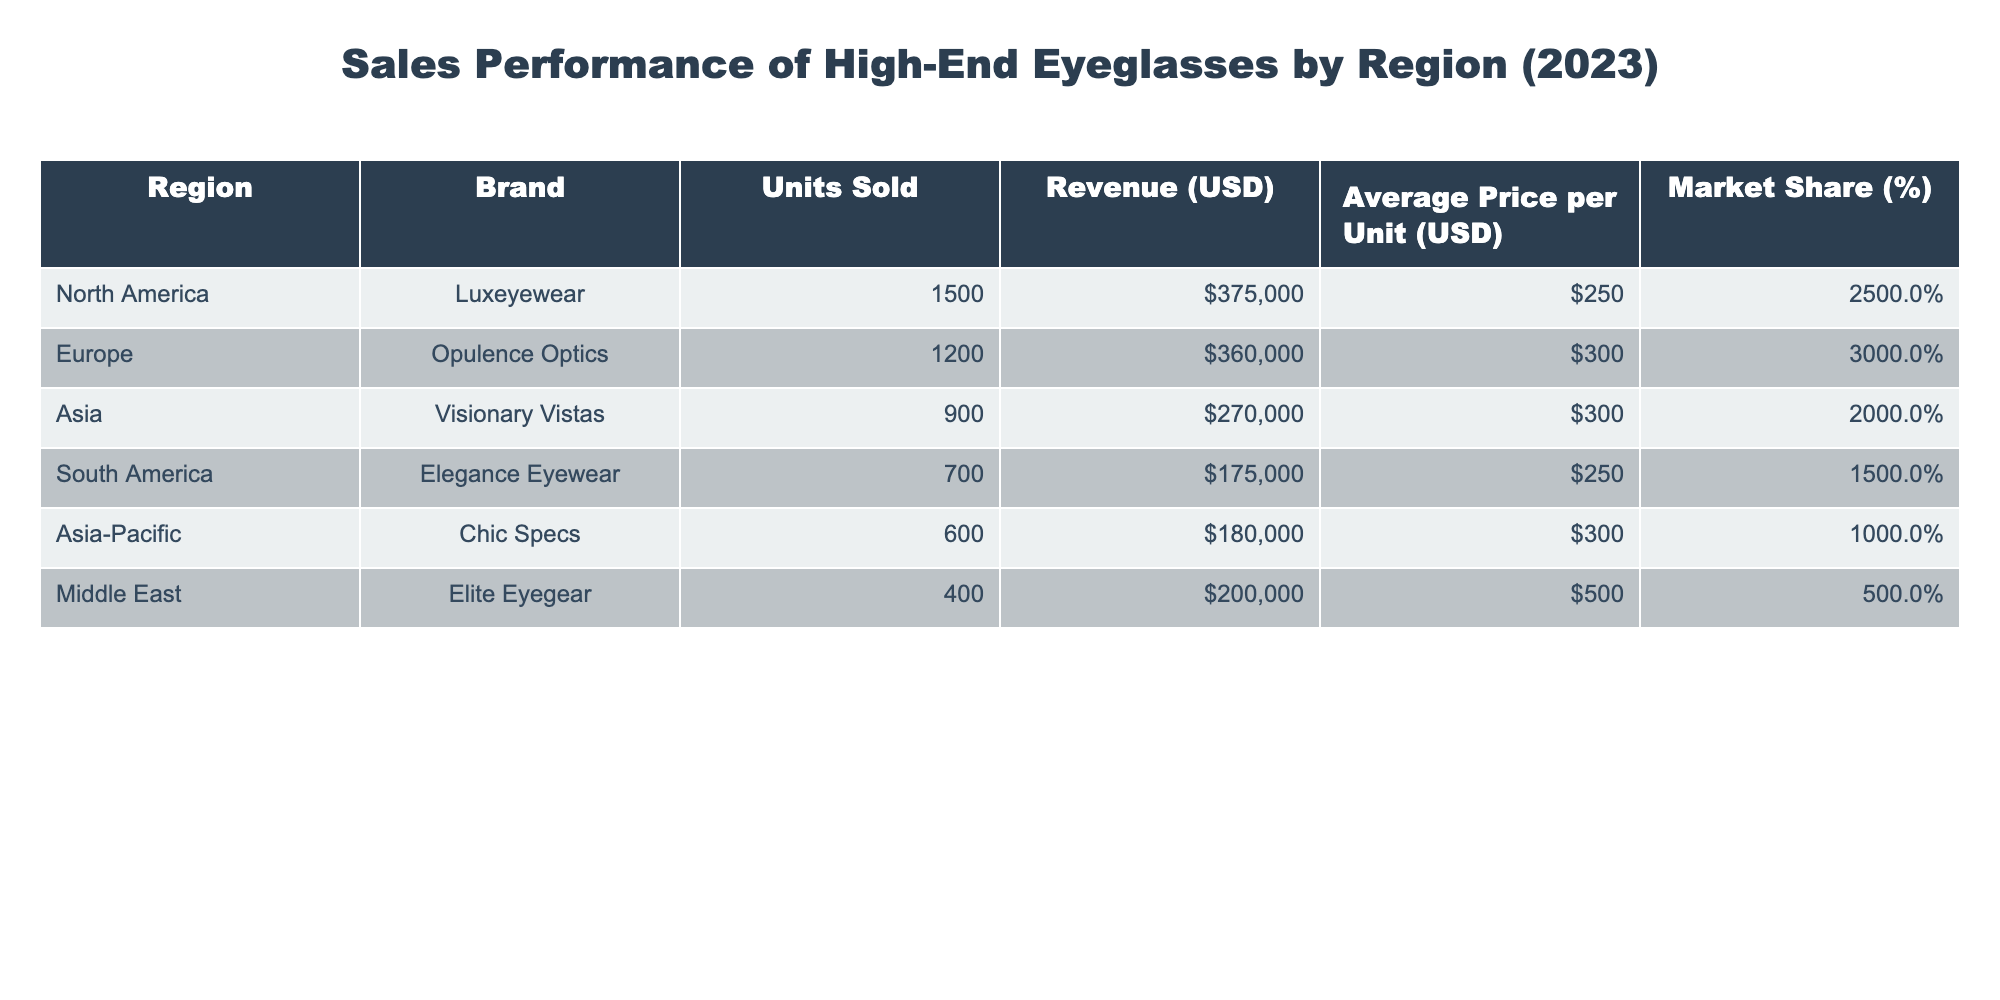What region has the highest average price per unit? Looking at the "Average Price per Unit (USD)" column, the Middle East has an average price of 500, which is the highest among all regions.
Answer: Middle East How many units were sold in North America? The "Units Sold" column shows that North America sold 1500 units.
Answer: 1500 What is the total revenue generated from sales in Europe and Asia combined? By adding the revenue from Europe (360000) and Asia (270000), the total revenue is 360000 + 270000 = 630000.
Answer: 630000 Does South America have a market share greater than 15 percent? The "Market Share (%)" for South America is 15, which is not greater than 15.
Answer: No Which brand sold the least number of units, and what is the corresponding revenue? The "Units Sold" for Elite Eyegear in the Middle East is 400, which is the lowest, and its revenue is 200000.
Answer: Elite Eyegear, 200000 What is the market share difference between Europe and North America? The market share for Europe is 30% and for North America is 25%. The difference is 30 - 25 = 5%.
Answer: 5% What percentage of total units sold came from Asia? The total units sold across all regions is 1500 + 1200 + 900 + 700 + 600 + 400 = 5100. From Asia, 900 units were sold. The percentage is (900 / 5100) * 100 ≈ 17.65%.
Answer: 17.65% Which region has a higher revenue, South America or Asia-Pacific? South America generated 175000 in revenue, while Asia-Pacific generated 180000. Therefore, Asia-Pacific has the higher revenue.
Answer: Asia-Pacific What can be inferred about the relationship between average price per unit and market share in this table? Generally, regions with a higher average price per unit, such as the Middle East (average price 500, market share 5%), have a lower market share, while regions with a lower average price per unit, like North America (average price 250, market share 25%), have a higher market share. This suggests an inverse relationship between average price and market share.
Answer: Inverse relationship 